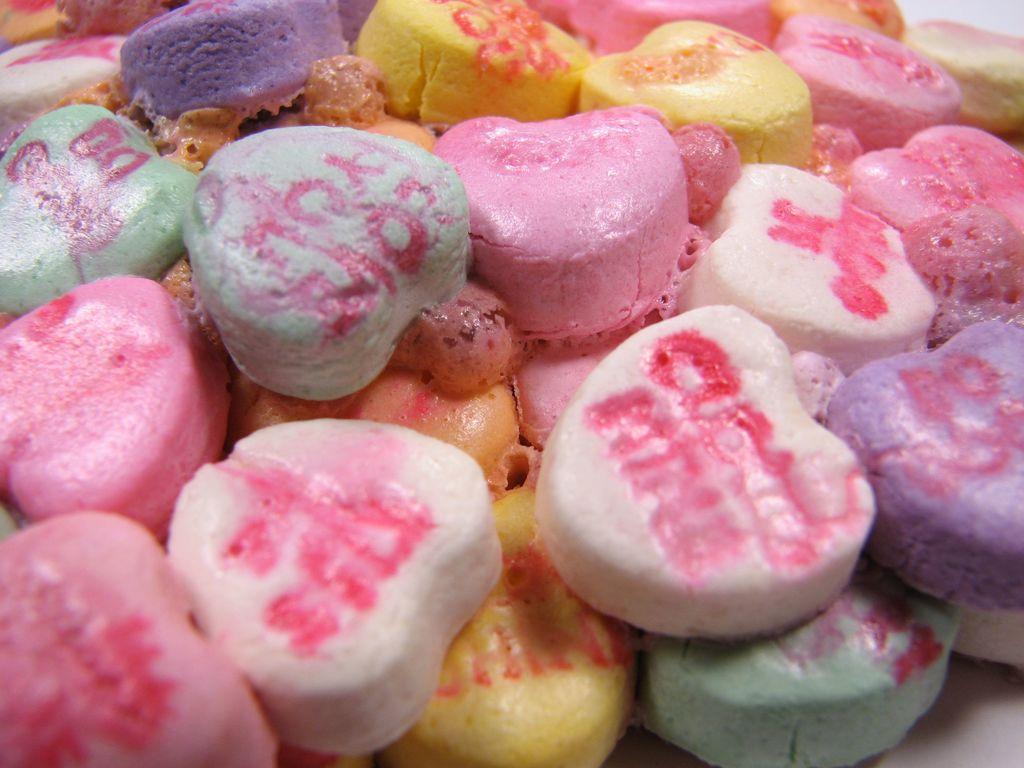How would you summarize this image in a sentence or two? There are candies in different colors arranged. And the background is white in color. 